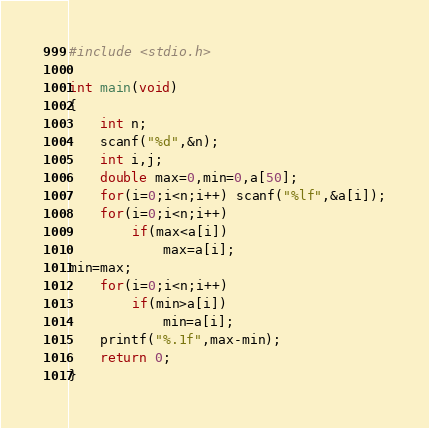Convert code to text. <code><loc_0><loc_0><loc_500><loc_500><_C_>#include <stdio.h>

int main(void)
{
	int n;
	scanf("%d",&n);
	int i,j;
	double max=0,min=0,a[50];
	for(i=0;i<n;i++) scanf("%lf",&a[i]);
	for(i=0;i<n;i++)
		if(max<a[i])
			max=a[i];
min=max;
	for(i=0;i<n;i++)
		if(min>a[i])
			min=a[i];
	printf("%.1f",max-min);
	return 0;
}</code> 